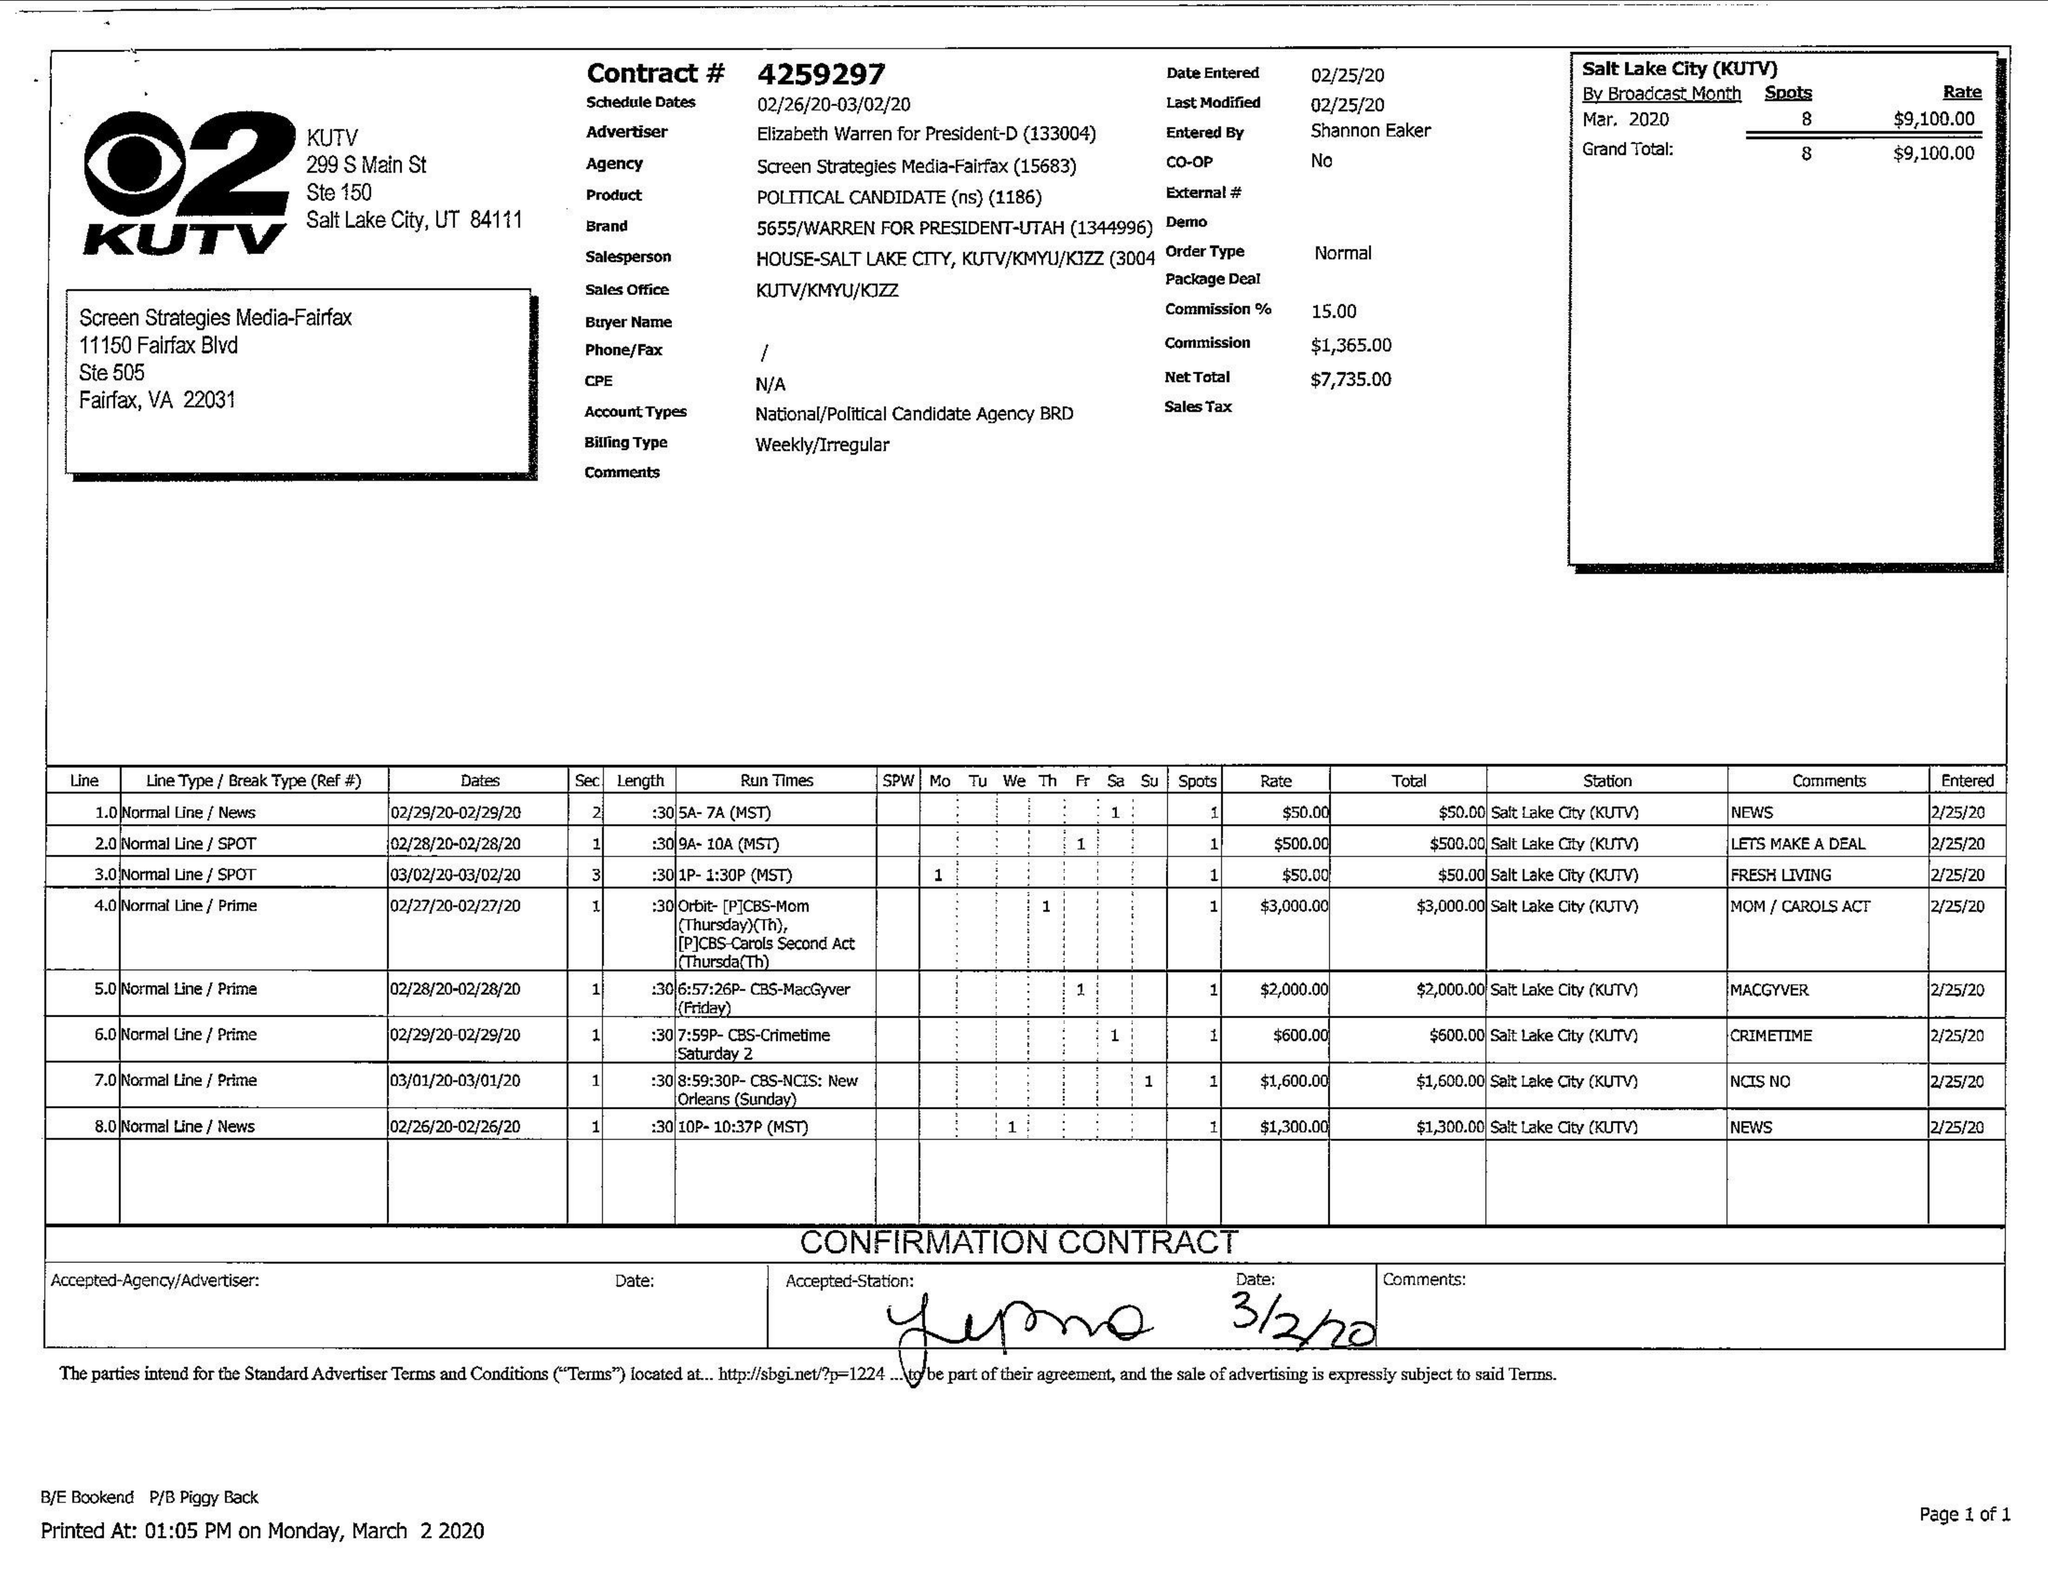What is the value for the advertiser?
Answer the question using a single word or phrase. ELIZABETH WARREN FOR PRESIDENT-D 